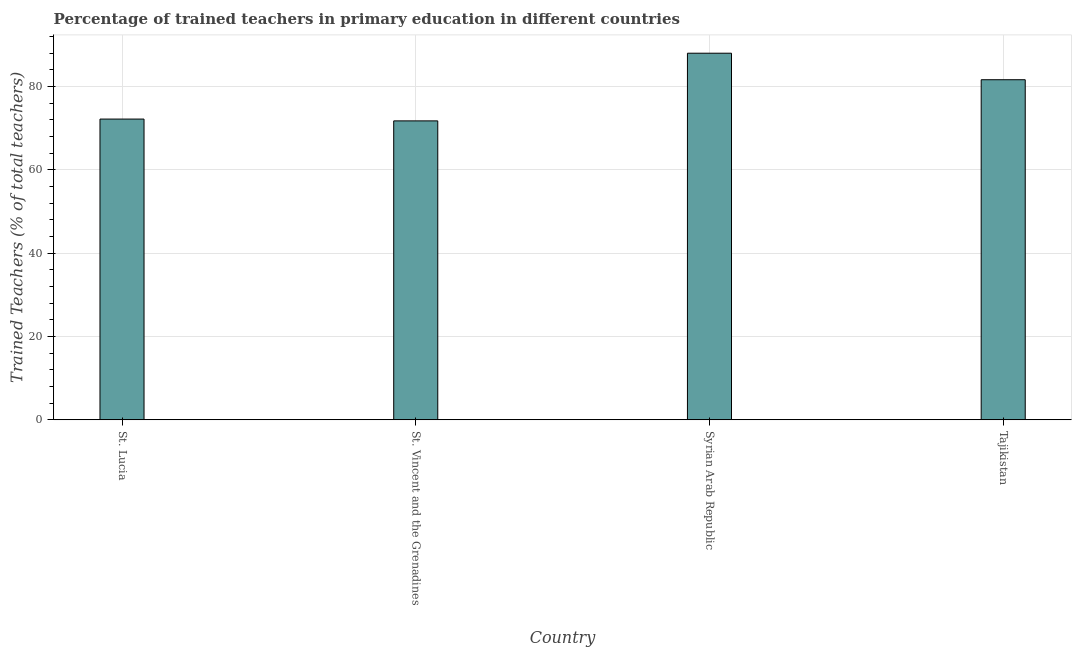Does the graph contain any zero values?
Give a very brief answer. No. Does the graph contain grids?
Your answer should be compact. Yes. What is the title of the graph?
Provide a short and direct response. Percentage of trained teachers in primary education in different countries. What is the label or title of the Y-axis?
Make the answer very short. Trained Teachers (% of total teachers). What is the percentage of trained teachers in Syrian Arab Republic?
Your answer should be very brief. 87.95. Across all countries, what is the maximum percentage of trained teachers?
Your answer should be compact. 87.95. Across all countries, what is the minimum percentage of trained teachers?
Make the answer very short. 71.71. In which country was the percentage of trained teachers maximum?
Keep it short and to the point. Syrian Arab Republic. In which country was the percentage of trained teachers minimum?
Provide a short and direct response. St. Vincent and the Grenadines. What is the sum of the percentage of trained teachers?
Offer a very short reply. 313.4. What is the difference between the percentage of trained teachers in St. Lucia and Syrian Arab Republic?
Give a very brief answer. -15.8. What is the average percentage of trained teachers per country?
Provide a short and direct response. 78.35. What is the median percentage of trained teachers?
Your response must be concise. 76.87. What is the ratio of the percentage of trained teachers in St. Vincent and the Grenadines to that in Tajikistan?
Your answer should be compact. 0.88. Is the percentage of trained teachers in St. Vincent and the Grenadines less than that in Tajikistan?
Keep it short and to the point. Yes. What is the difference between the highest and the second highest percentage of trained teachers?
Ensure brevity in your answer.  6.36. Is the sum of the percentage of trained teachers in St. Vincent and the Grenadines and Tajikistan greater than the maximum percentage of trained teachers across all countries?
Your response must be concise. Yes. What is the difference between the highest and the lowest percentage of trained teachers?
Ensure brevity in your answer.  16.24. In how many countries, is the percentage of trained teachers greater than the average percentage of trained teachers taken over all countries?
Provide a succinct answer. 2. How many bars are there?
Your answer should be compact. 4. Are all the bars in the graph horizontal?
Keep it short and to the point. No. How many countries are there in the graph?
Your answer should be very brief. 4. What is the Trained Teachers (% of total teachers) of St. Lucia?
Give a very brief answer. 72.15. What is the Trained Teachers (% of total teachers) in St. Vincent and the Grenadines?
Provide a short and direct response. 71.71. What is the Trained Teachers (% of total teachers) of Syrian Arab Republic?
Offer a very short reply. 87.95. What is the Trained Teachers (% of total teachers) of Tajikistan?
Provide a succinct answer. 81.59. What is the difference between the Trained Teachers (% of total teachers) in St. Lucia and St. Vincent and the Grenadines?
Give a very brief answer. 0.44. What is the difference between the Trained Teachers (% of total teachers) in St. Lucia and Syrian Arab Republic?
Offer a very short reply. -15.8. What is the difference between the Trained Teachers (% of total teachers) in St. Lucia and Tajikistan?
Give a very brief answer. -9.44. What is the difference between the Trained Teachers (% of total teachers) in St. Vincent and the Grenadines and Syrian Arab Republic?
Keep it short and to the point. -16.24. What is the difference between the Trained Teachers (% of total teachers) in St. Vincent and the Grenadines and Tajikistan?
Keep it short and to the point. -9.88. What is the difference between the Trained Teachers (% of total teachers) in Syrian Arab Republic and Tajikistan?
Provide a short and direct response. 6.36. What is the ratio of the Trained Teachers (% of total teachers) in St. Lucia to that in Syrian Arab Republic?
Your answer should be very brief. 0.82. What is the ratio of the Trained Teachers (% of total teachers) in St. Lucia to that in Tajikistan?
Your answer should be very brief. 0.88. What is the ratio of the Trained Teachers (% of total teachers) in St. Vincent and the Grenadines to that in Syrian Arab Republic?
Offer a terse response. 0.81. What is the ratio of the Trained Teachers (% of total teachers) in St. Vincent and the Grenadines to that in Tajikistan?
Offer a terse response. 0.88. What is the ratio of the Trained Teachers (% of total teachers) in Syrian Arab Republic to that in Tajikistan?
Give a very brief answer. 1.08. 